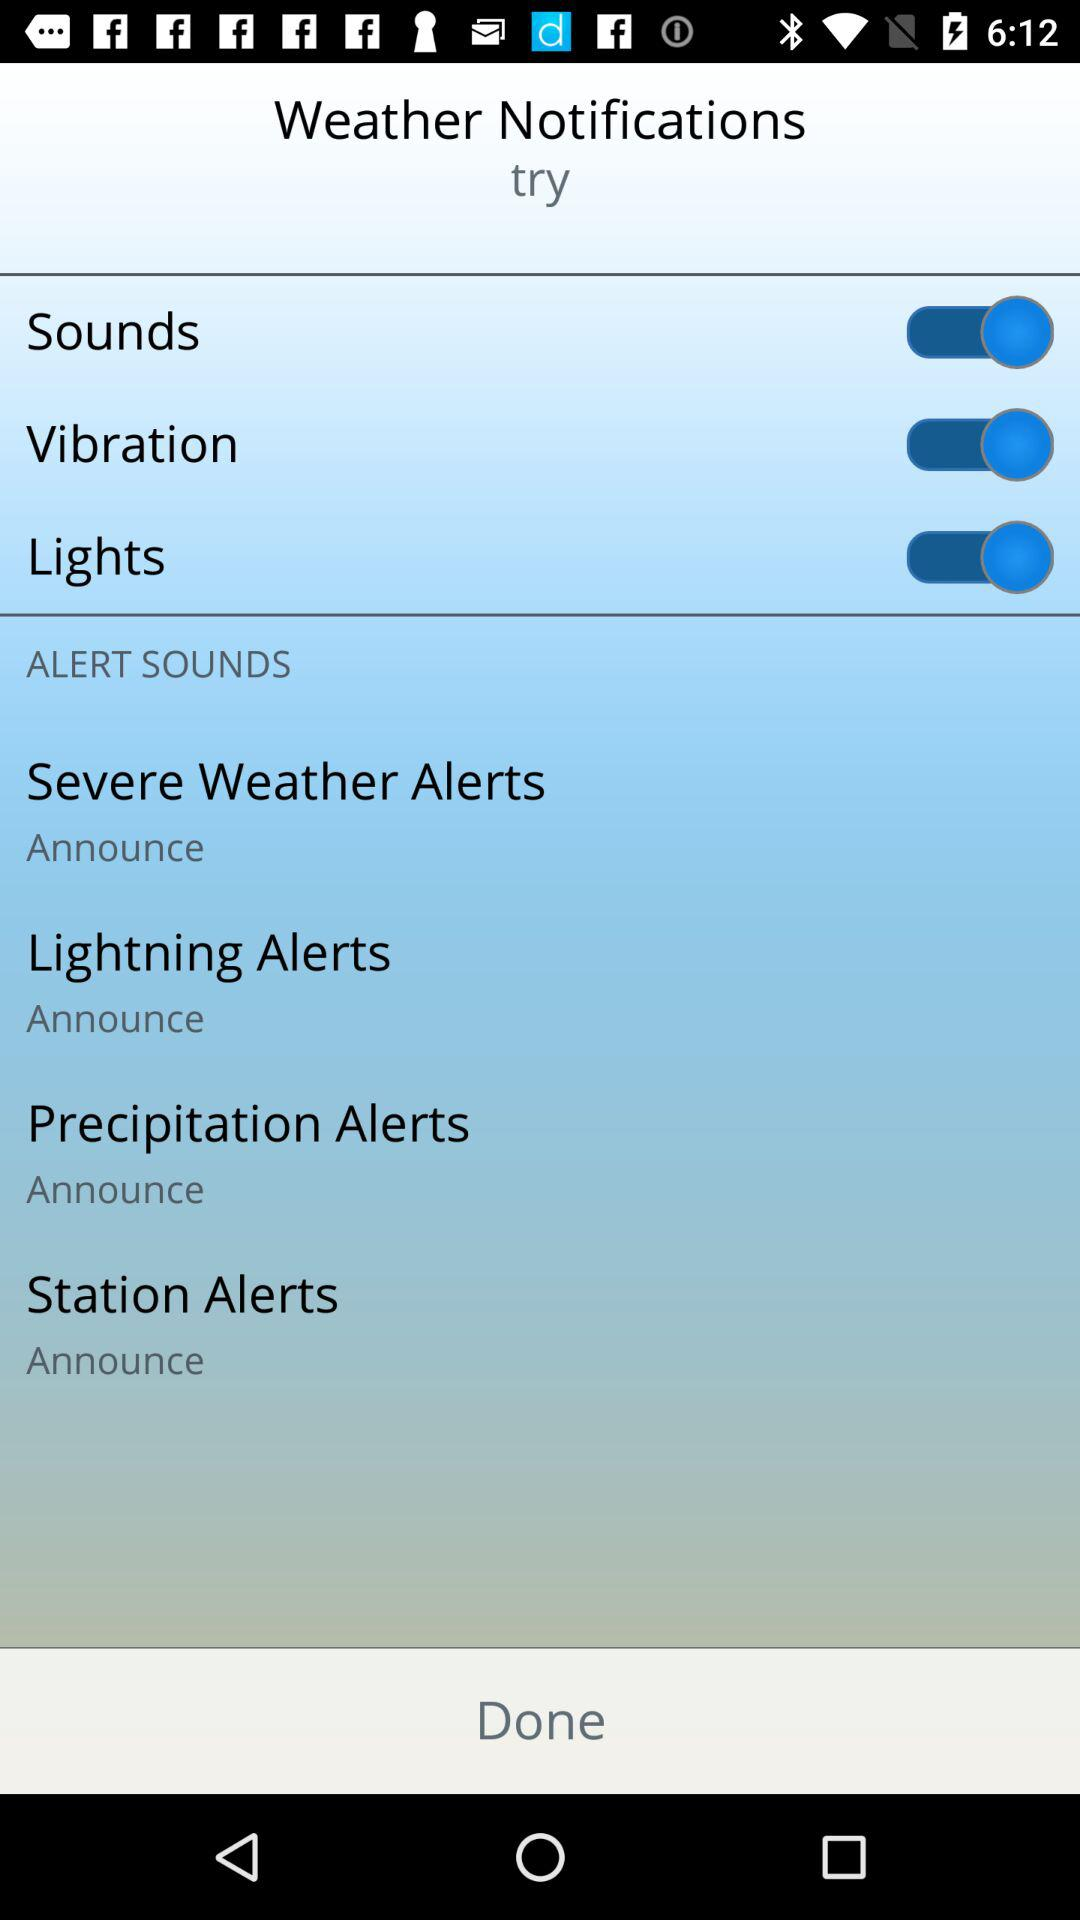What is the status of "Vibration"? The status of "Vibration" is "on". 